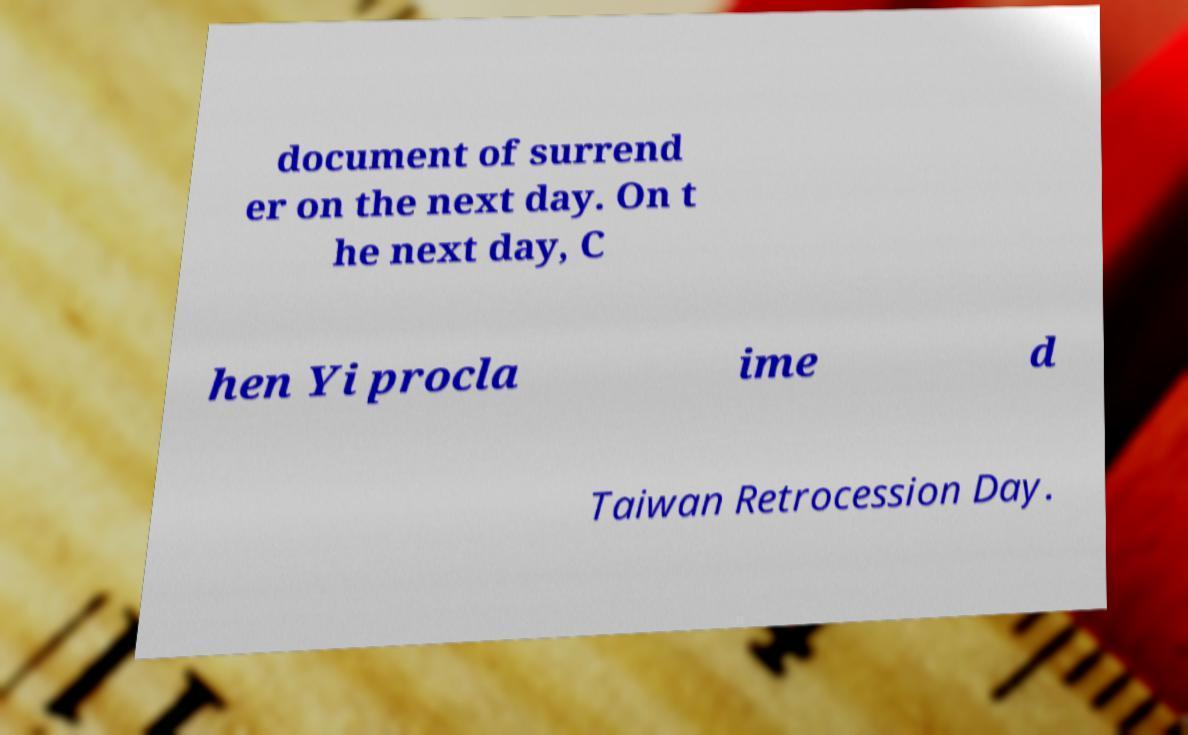Can you read and provide the text displayed in the image?This photo seems to have some interesting text. Can you extract and type it out for me? document of surrend er on the next day. On t he next day, C hen Yi procla ime d Taiwan Retrocession Day. 